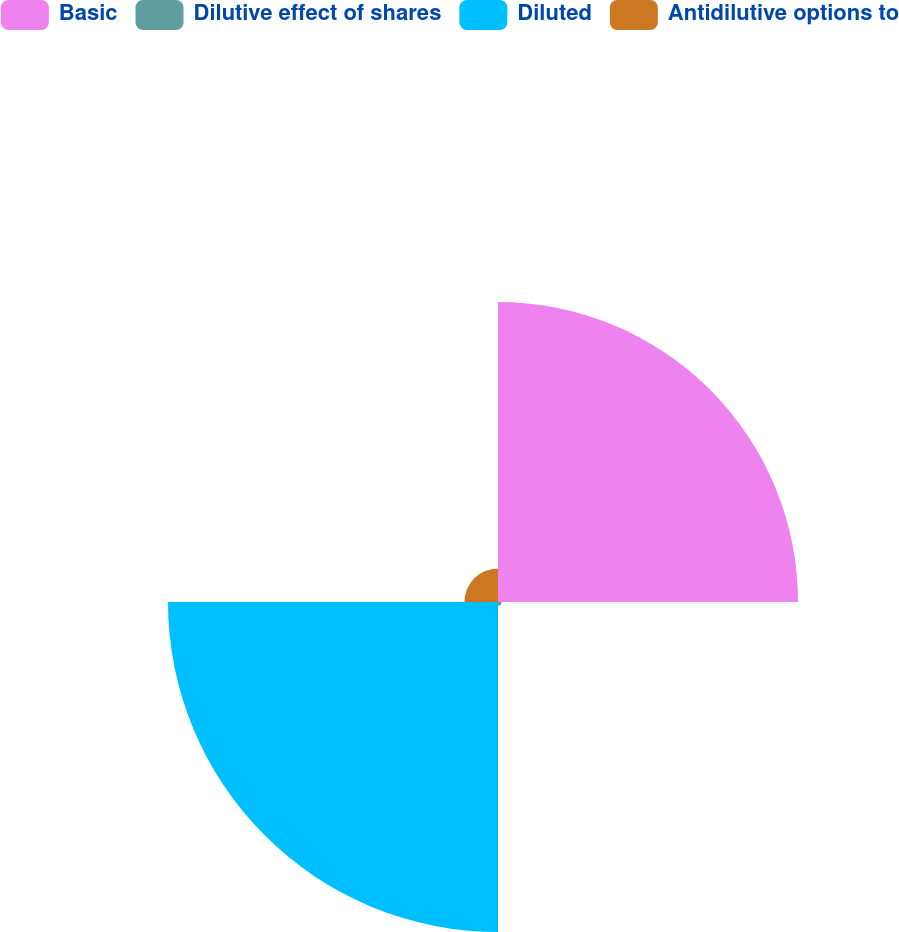<chart> <loc_0><loc_0><loc_500><loc_500><pie_chart><fcel>Basic<fcel>Dilutive effect of shares<fcel>Diluted<fcel>Antidilutive options to<nl><fcel>44.97%<fcel>0.54%<fcel>49.46%<fcel>5.03%<nl></chart> 